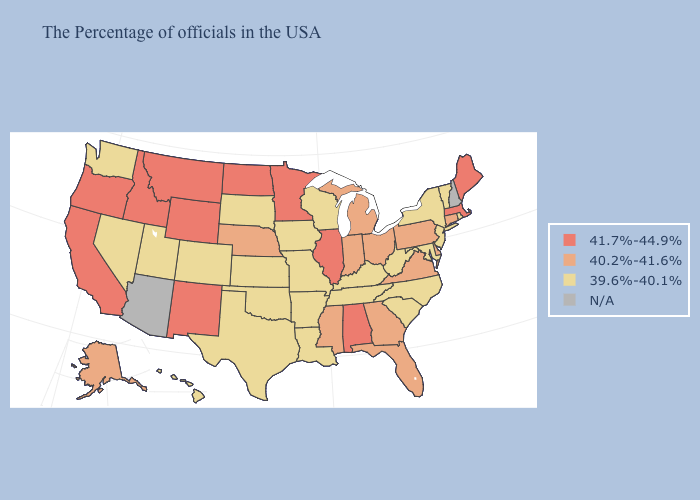Name the states that have a value in the range N/A?
Concise answer only. New Hampshire, Arizona. What is the value of Mississippi?
Be succinct. 40.2%-41.6%. Name the states that have a value in the range N/A?
Short answer required. New Hampshire, Arizona. Which states have the lowest value in the USA?
Quick response, please. Rhode Island, Vermont, New York, New Jersey, Maryland, North Carolina, South Carolina, West Virginia, Kentucky, Tennessee, Wisconsin, Louisiana, Missouri, Arkansas, Iowa, Kansas, Oklahoma, Texas, South Dakota, Colorado, Utah, Nevada, Washington, Hawaii. Which states hav the highest value in the South?
Give a very brief answer. Alabama. Among the states that border New Hampshire , which have the highest value?
Keep it brief. Maine, Massachusetts. Does Kentucky have the highest value in the USA?
Short answer required. No. Name the states that have a value in the range 40.2%-41.6%?
Quick response, please. Connecticut, Delaware, Pennsylvania, Virginia, Ohio, Florida, Georgia, Michigan, Indiana, Mississippi, Nebraska, Alaska. Among the states that border West Virginia , which have the lowest value?
Quick response, please. Maryland, Kentucky. What is the value of Alabama?
Be succinct. 41.7%-44.9%. What is the highest value in the USA?
Answer briefly. 41.7%-44.9%. Name the states that have a value in the range 40.2%-41.6%?
Be succinct. Connecticut, Delaware, Pennsylvania, Virginia, Ohio, Florida, Georgia, Michigan, Indiana, Mississippi, Nebraska, Alaska. Name the states that have a value in the range 39.6%-40.1%?
Quick response, please. Rhode Island, Vermont, New York, New Jersey, Maryland, North Carolina, South Carolina, West Virginia, Kentucky, Tennessee, Wisconsin, Louisiana, Missouri, Arkansas, Iowa, Kansas, Oklahoma, Texas, South Dakota, Colorado, Utah, Nevada, Washington, Hawaii. Name the states that have a value in the range 40.2%-41.6%?
Quick response, please. Connecticut, Delaware, Pennsylvania, Virginia, Ohio, Florida, Georgia, Michigan, Indiana, Mississippi, Nebraska, Alaska. What is the value of Maine?
Quick response, please. 41.7%-44.9%. 